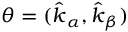Convert formula to latex. <formula><loc_0><loc_0><loc_500><loc_500>{ \theta = ( \hat { k } _ { \alpha } , \hat { k } _ { \beta } ) }</formula> 